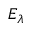<formula> <loc_0><loc_0><loc_500><loc_500>E _ { \lambda }</formula> 